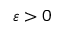Convert formula to latex. <formula><loc_0><loc_0><loc_500><loc_500>\varepsilon > 0</formula> 